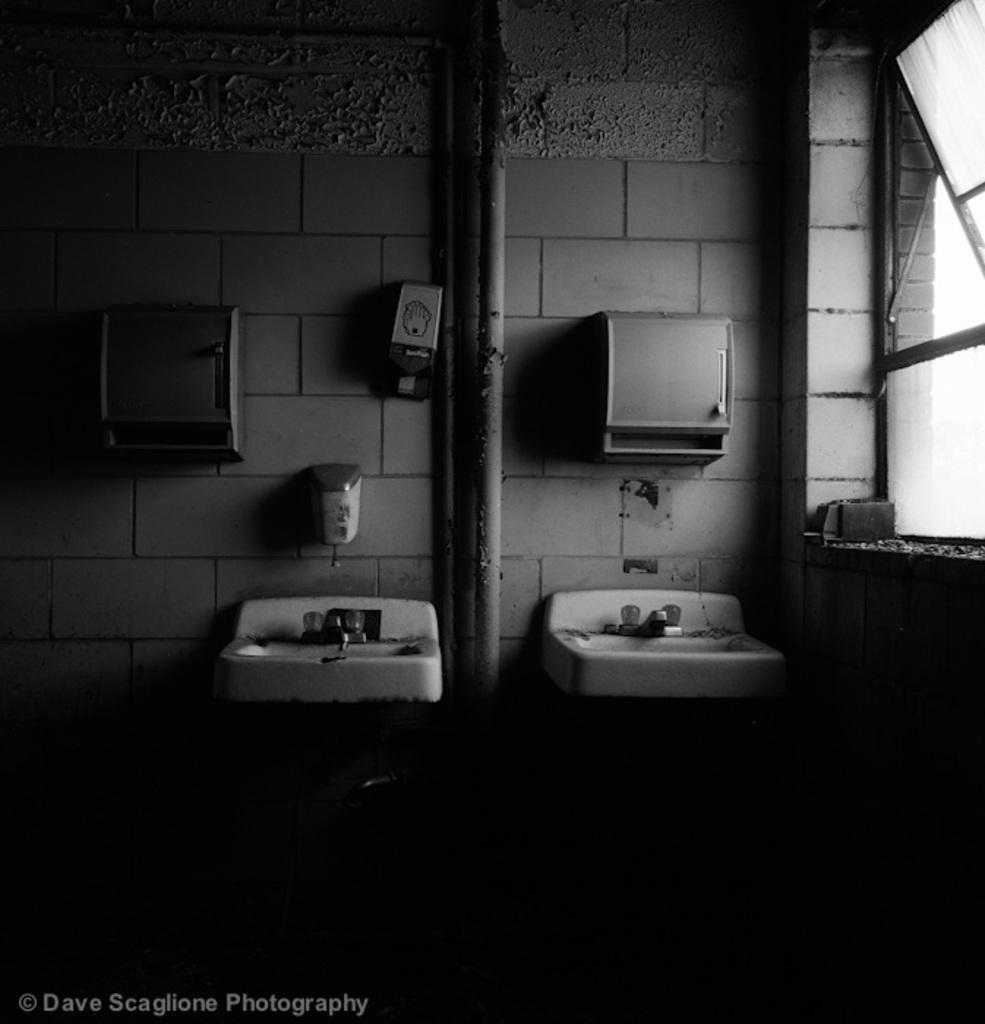How many wash basins are visible in the image? There are 2 wash basins in the image. What other objects can be seen in the image? There are pipes and boxes on the wall visible in the image. Where is the window located in the image? The window is on the right side of the image. What is the color scheme of the image? The image is black and white. How many pies are being baked in the image? There are no pies or any indication of baking in the image. What is the rate of dirt accumulation in the image? There is no dirt visible in the image, so it is not possible to determine a rate of accumulation. 